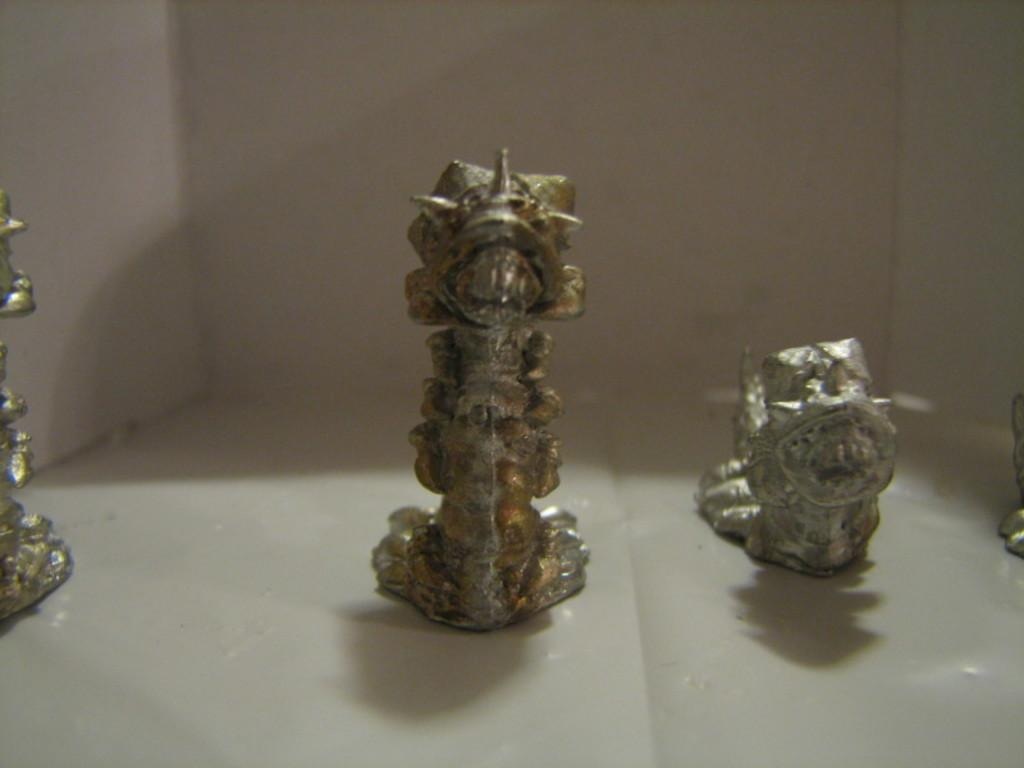How many objects are placed on the floor in the image? There are four objects placed on the floor in the image. What can be seen in the background of the image? There is a wall in the background of the image. What day of the week is depicted in the image? The image does not depict a day of the week; it only shows four objects on the floor and a wall in the background. 